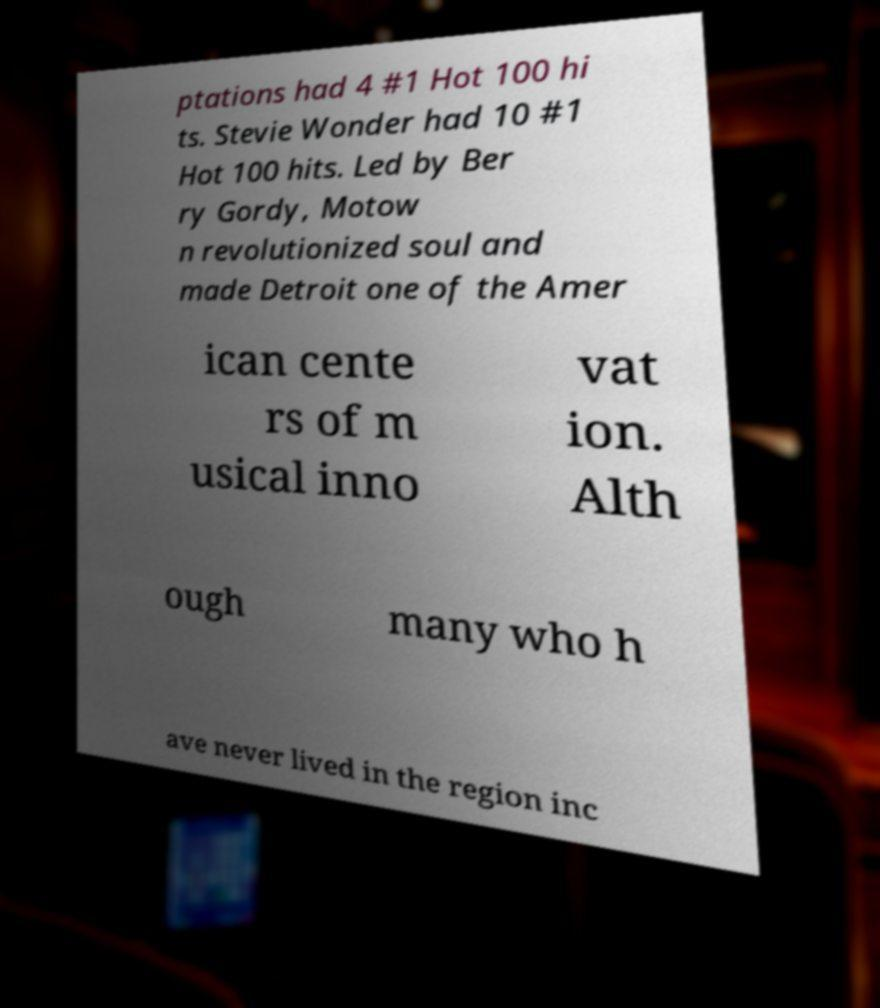Please identify and transcribe the text found in this image. ptations had 4 #1 Hot 100 hi ts. Stevie Wonder had 10 #1 Hot 100 hits. Led by Ber ry Gordy, Motow n revolutionized soul and made Detroit one of the Amer ican cente rs of m usical inno vat ion. Alth ough many who h ave never lived in the region inc 